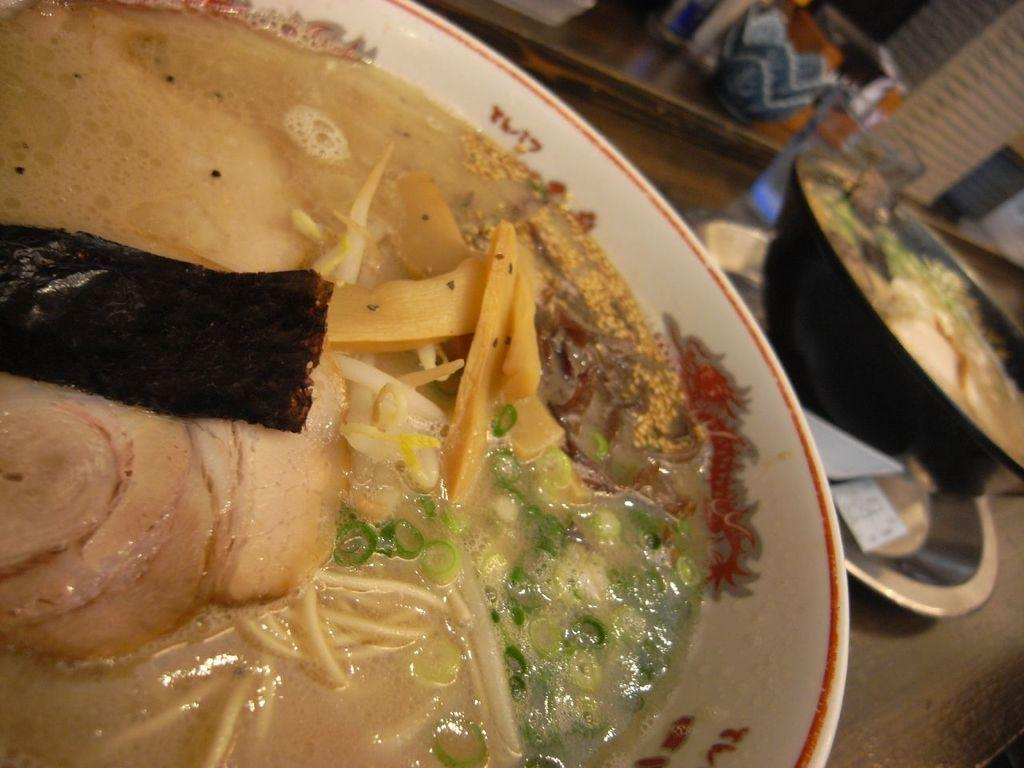What is in the bowls that are visible in the image? There are food items in the bowls. What type of container is on the table? There is a glass on the table. What is another type of dish on the table? There is a plate on the table. What other objects can be seen on the table? There are other objects on the table. Where is the nearest zoo in relation to the table in the image? There is no information about a zoo or its location in the image. 